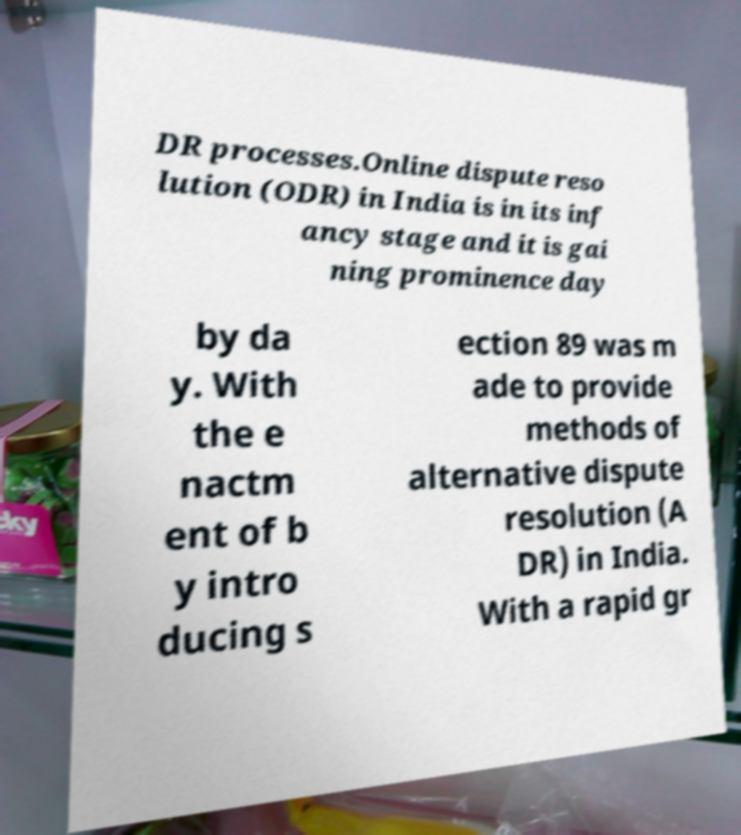Please read and relay the text visible in this image. What does it say? DR processes.Online dispute reso lution (ODR) in India is in its inf ancy stage and it is gai ning prominence day by da y. With the e nactm ent of b y intro ducing s ection 89 was m ade to provide methods of alternative dispute resolution (A DR) in India. With a rapid gr 